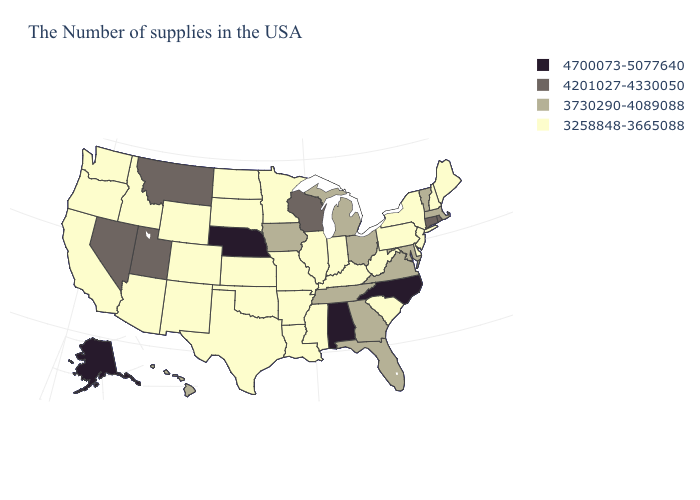Does Colorado have the lowest value in the West?
Answer briefly. Yes. Name the states that have a value in the range 3730290-4089088?
Be succinct. Massachusetts, Vermont, Maryland, Virginia, Ohio, Florida, Georgia, Michigan, Tennessee, Iowa, Hawaii. Does Tennessee have the highest value in the USA?
Short answer required. No. What is the value of Minnesota?
Quick response, please. 3258848-3665088. What is the value of Kansas?
Keep it brief. 3258848-3665088. Which states have the lowest value in the USA?
Write a very short answer. Maine, New Hampshire, New York, New Jersey, Delaware, Pennsylvania, South Carolina, West Virginia, Kentucky, Indiana, Illinois, Mississippi, Louisiana, Missouri, Arkansas, Minnesota, Kansas, Oklahoma, Texas, South Dakota, North Dakota, Wyoming, Colorado, New Mexico, Arizona, Idaho, California, Washington, Oregon. Does Connecticut have the lowest value in the Northeast?
Keep it brief. No. Which states have the lowest value in the USA?
Keep it brief. Maine, New Hampshire, New York, New Jersey, Delaware, Pennsylvania, South Carolina, West Virginia, Kentucky, Indiana, Illinois, Mississippi, Louisiana, Missouri, Arkansas, Minnesota, Kansas, Oklahoma, Texas, South Dakota, North Dakota, Wyoming, Colorado, New Mexico, Arizona, Idaho, California, Washington, Oregon. Name the states that have a value in the range 4201027-4330050?
Give a very brief answer. Rhode Island, Connecticut, Wisconsin, Utah, Montana, Nevada. What is the lowest value in the Northeast?
Give a very brief answer. 3258848-3665088. Does the map have missing data?
Quick response, please. No. What is the value of Wyoming?
Concise answer only. 3258848-3665088. Is the legend a continuous bar?
Give a very brief answer. No. Which states hav the highest value in the Northeast?
Be succinct. Rhode Island, Connecticut. Name the states that have a value in the range 4700073-5077640?
Write a very short answer. North Carolina, Alabama, Nebraska, Alaska. 